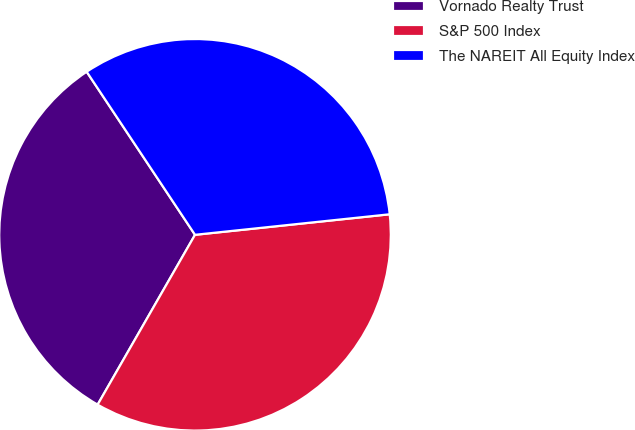Convert chart. <chart><loc_0><loc_0><loc_500><loc_500><pie_chart><fcel>Vornado Realty Trust<fcel>S&P 500 Index<fcel>The NAREIT All Equity Index<nl><fcel>32.38%<fcel>34.96%<fcel>32.66%<nl></chart> 